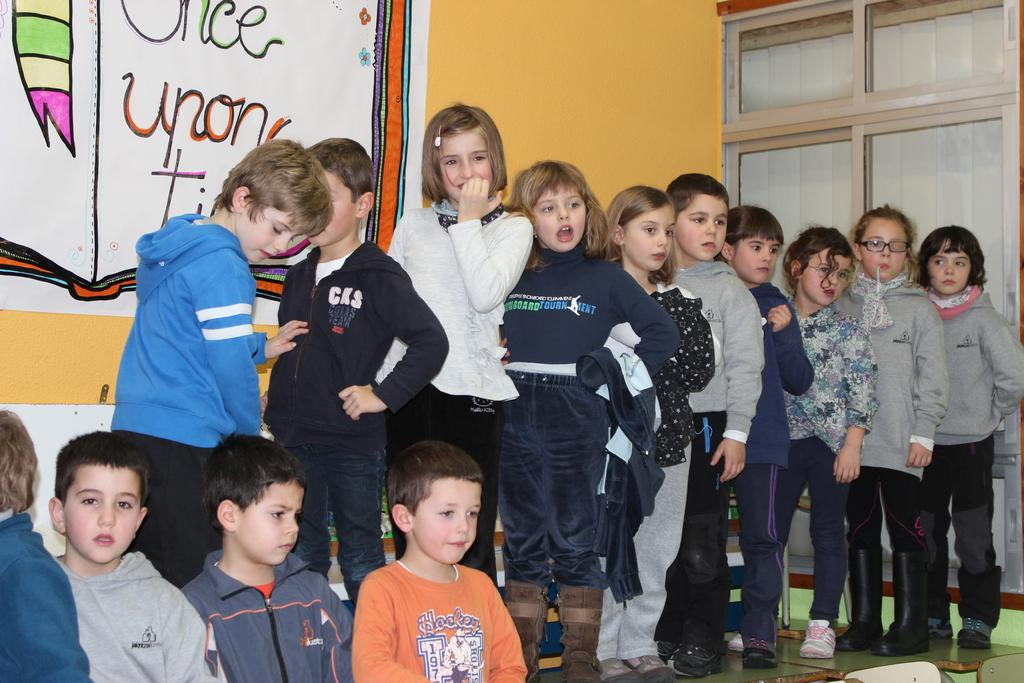What is happening on the stage in the image? There is a group of children on the stage. What can be seen in the background behind the children? There are posters and a window in the background. How many ladybugs are crawling on the children's faces in the image? There are no ladybugs present in the image. What type of bait is being used to attract the children to the stage? There is no bait present in the image, and the children are not being attracted to the stage. 